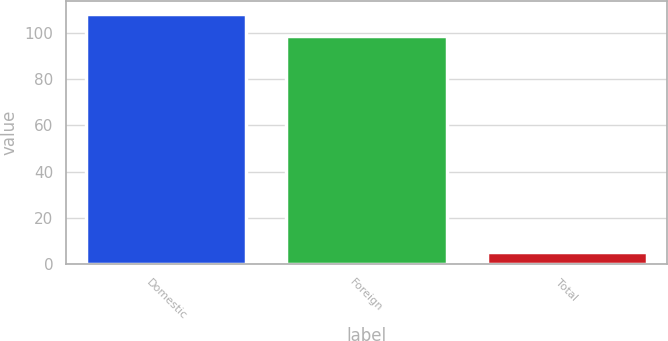Convert chart. <chart><loc_0><loc_0><loc_500><loc_500><bar_chart><fcel>Domestic<fcel>Foreign<fcel>Total<nl><fcel>108.35<fcel>98.5<fcel>5<nl></chart> 